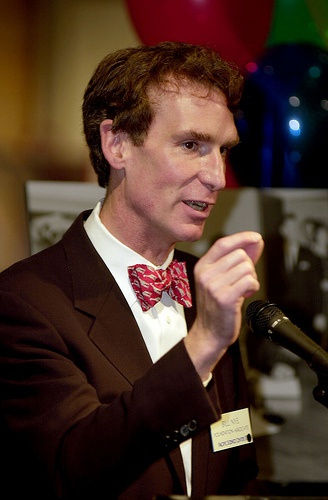Describe the objects in this image and their specific colors. I can see people in maroon, black, brown, and tan tones and tie in maroon, brown, and darkgray tones in this image. 